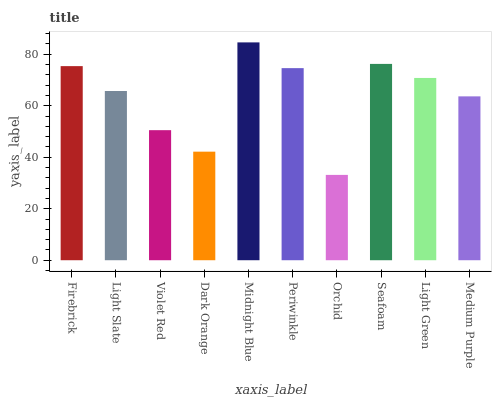Is Orchid the minimum?
Answer yes or no. Yes. Is Midnight Blue the maximum?
Answer yes or no. Yes. Is Light Slate the minimum?
Answer yes or no. No. Is Light Slate the maximum?
Answer yes or no. No. Is Firebrick greater than Light Slate?
Answer yes or no. Yes. Is Light Slate less than Firebrick?
Answer yes or no. Yes. Is Light Slate greater than Firebrick?
Answer yes or no. No. Is Firebrick less than Light Slate?
Answer yes or no. No. Is Light Green the high median?
Answer yes or no. Yes. Is Light Slate the low median?
Answer yes or no. Yes. Is Seafoam the high median?
Answer yes or no. No. Is Orchid the low median?
Answer yes or no. No. 